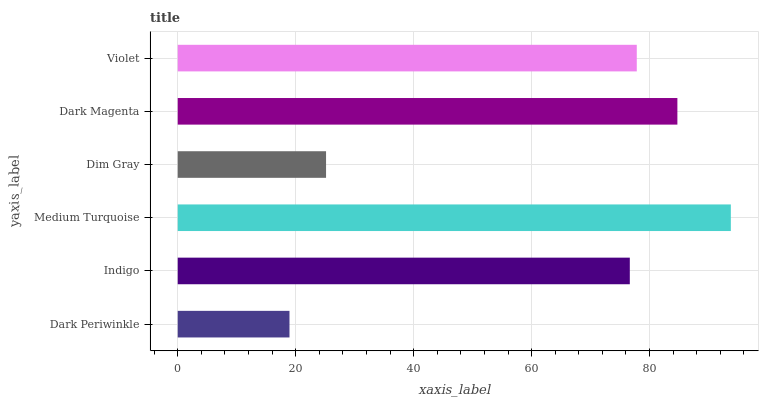Is Dark Periwinkle the minimum?
Answer yes or no. Yes. Is Medium Turquoise the maximum?
Answer yes or no. Yes. Is Indigo the minimum?
Answer yes or no. No. Is Indigo the maximum?
Answer yes or no. No. Is Indigo greater than Dark Periwinkle?
Answer yes or no. Yes. Is Dark Periwinkle less than Indigo?
Answer yes or no. Yes. Is Dark Periwinkle greater than Indigo?
Answer yes or no. No. Is Indigo less than Dark Periwinkle?
Answer yes or no. No. Is Violet the high median?
Answer yes or no. Yes. Is Indigo the low median?
Answer yes or no. Yes. Is Indigo the high median?
Answer yes or no. No. Is Dark Magenta the low median?
Answer yes or no. No. 